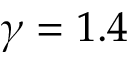Convert formula to latex. <formula><loc_0><loc_0><loc_500><loc_500>\gamma = 1 . 4</formula> 